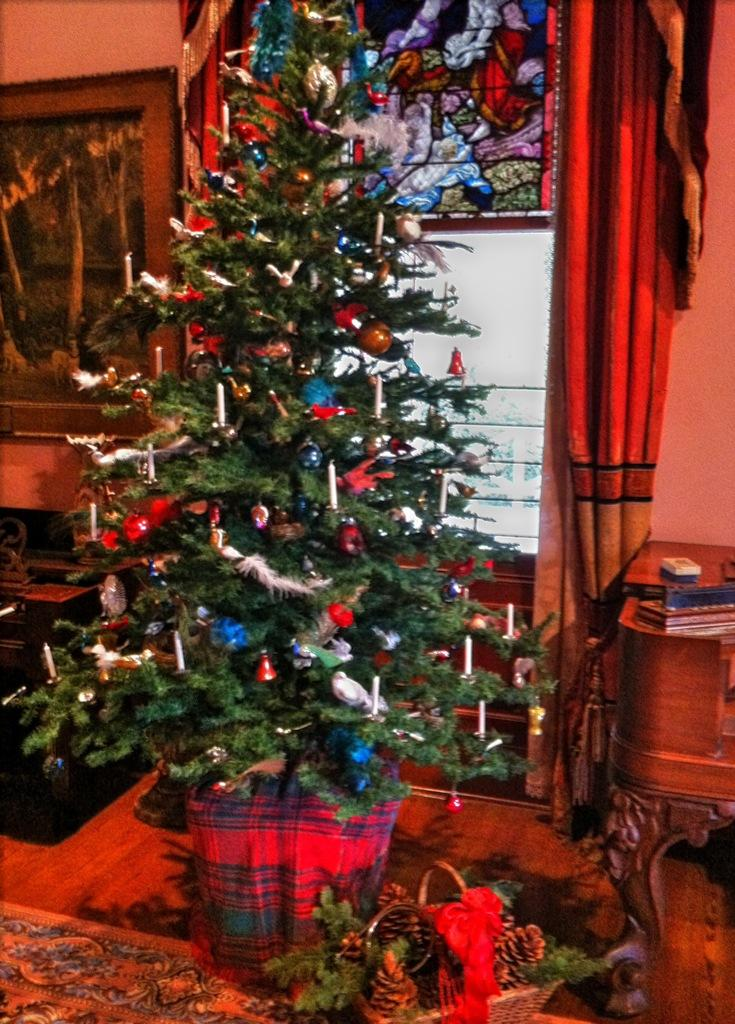What type of tree is decorated in the image? There is a decorated Christmas tree in the image. What type of window treatment is present in the image? There are curtains in the image. What type of objects are present in the image? There are photo frames in the image. What type of opening is visible in the image? There is a window in the image. What type of surface is visible in the image? There is a wall visible in the image. Who gave their approval for the decoration of the Christmas tree in the image? There is no information about who gave their approval for the decoration of the Christmas tree in the image. 